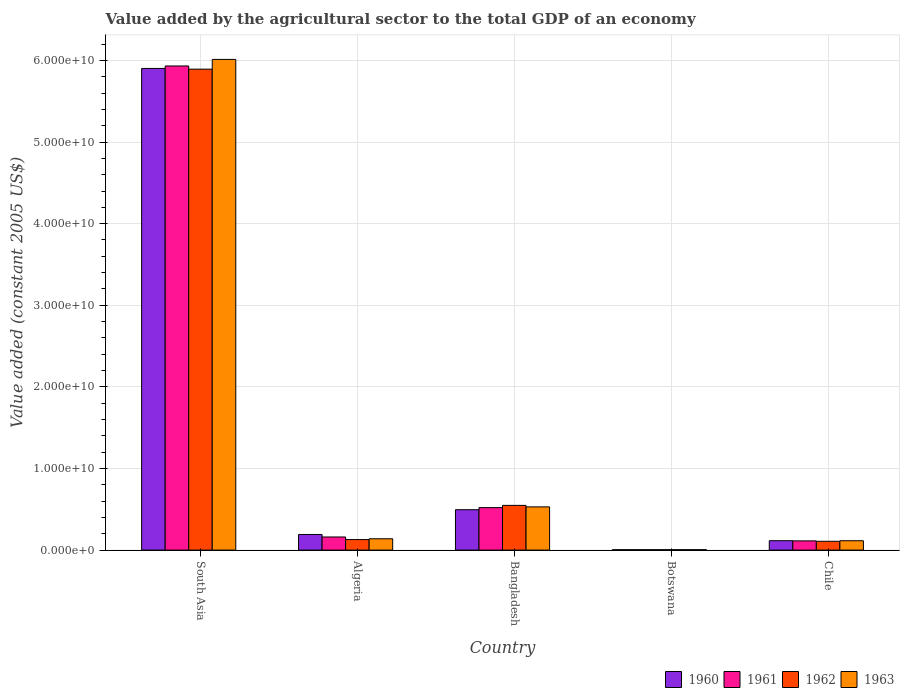How many different coloured bars are there?
Make the answer very short. 4. Are the number of bars per tick equal to the number of legend labels?
Provide a succinct answer. Yes. How many bars are there on the 1st tick from the left?
Your answer should be compact. 4. What is the label of the 4th group of bars from the left?
Provide a succinct answer. Botswana. In how many cases, is the number of bars for a given country not equal to the number of legend labels?
Give a very brief answer. 0. What is the value added by the agricultural sector in 1961 in Botswana?
Offer a terse response. 4.86e+07. Across all countries, what is the maximum value added by the agricultural sector in 1963?
Offer a terse response. 6.01e+1. Across all countries, what is the minimum value added by the agricultural sector in 1962?
Your answer should be compact. 5.04e+07. In which country was the value added by the agricultural sector in 1960 maximum?
Offer a very short reply. South Asia. In which country was the value added by the agricultural sector in 1960 minimum?
Make the answer very short. Botswana. What is the total value added by the agricultural sector in 1960 in the graph?
Your answer should be compact. 6.71e+1. What is the difference between the value added by the agricultural sector in 1963 in Bangladesh and that in South Asia?
Offer a very short reply. -5.48e+1. What is the difference between the value added by the agricultural sector in 1960 in Botswana and the value added by the agricultural sector in 1962 in Algeria?
Ensure brevity in your answer.  -1.24e+09. What is the average value added by the agricultural sector in 1961 per country?
Your response must be concise. 1.35e+1. What is the difference between the value added by the agricultural sector of/in 1963 and value added by the agricultural sector of/in 1962 in Botswana?
Ensure brevity in your answer.  1.75e+06. What is the ratio of the value added by the agricultural sector in 1962 in Bangladesh to that in South Asia?
Your answer should be very brief. 0.09. Is the value added by the agricultural sector in 1963 in Botswana less than that in Chile?
Make the answer very short. Yes. What is the difference between the highest and the second highest value added by the agricultural sector in 1960?
Your answer should be very brief. -3.03e+09. What is the difference between the highest and the lowest value added by the agricultural sector in 1963?
Your answer should be very brief. 6.01e+1. In how many countries, is the value added by the agricultural sector in 1962 greater than the average value added by the agricultural sector in 1962 taken over all countries?
Keep it short and to the point. 1. Is the sum of the value added by the agricultural sector in 1960 in Botswana and South Asia greater than the maximum value added by the agricultural sector in 1962 across all countries?
Make the answer very short. Yes. What does the 3rd bar from the right in South Asia represents?
Offer a very short reply. 1961. Are all the bars in the graph horizontal?
Ensure brevity in your answer.  No. How many countries are there in the graph?
Offer a terse response. 5. What is the difference between two consecutive major ticks on the Y-axis?
Provide a short and direct response. 1.00e+1. Are the values on the major ticks of Y-axis written in scientific E-notation?
Provide a short and direct response. Yes. Where does the legend appear in the graph?
Your answer should be very brief. Bottom right. How many legend labels are there?
Your answer should be compact. 4. What is the title of the graph?
Give a very brief answer. Value added by the agricultural sector to the total GDP of an economy. What is the label or title of the X-axis?
Your answer should be compact. Country. What is the label or title of the Y-axis?
Your answer should be very brief. Value added (constant 2005 US$). What is the Value added (constant 2005 US$) in 1960 in South Asia?
Make the answer very short. 5.90e+1. What is the Value added (constant 2005 US$) of 1961 in South Asia?
Your response must be concise. 5.93e+1. What is the Value added (constant 2005 US$) of 1962 in South Asia?
Your answer should be very brief. 5.89e+1. What is the Value added (constant 2005 US$) in 1963 in South Asia?
Give a very brief answer. 6.01e+1. What is the Value added (constant 2005 US$) in 1960 in Algeria?
Provide a succinct answer. 1.92e+09. What is the Value added (constant 2005 US$) in 1961 in Algeria?
Offer a very short reply. 1.61e+09. What is the Value added (constant 2005 US$) in 1962 in Algeria?
Offer a terse response. 1.29e+09. What is the Value added (constant 2005 US$) of 1963 in Algeria?
Ensure brevity in your answer.  1.39e+09. What is the Value added (constant 2005 US$) in 1960 in Bangladesh?
Provide a succinct answer. 4.95e+09. What is the Value added (constant 2005 US$) in 1961 in Bangladesh?
Provide a short and direct response. 5.21e+09. What is the Value added (constant 2005 US$) of 1962 in Bangladesh?
Provide a short and direct response. 5.48e+09. What is the Value added (constant 2005 US$) of 1963 in Bangladesh?
Offer a terse response. 5.30e+09. What is the Value added (constant 2005 US$) of 1960 in Botswana?
Make the answer very short. 4.74e+07. What is the Value added (constant 2005 US$) in 1961 in Botswana?
Make the answer very short. 4.86e+07. What is the Value added (constant 2005 US$) of 1962 in Botswana?
Give a very brief answer. 5.04e+07. What is the Value added (constant 2005 US$) of 1963 in Botswana?
Provide a succinct answer. 5.21e+07. What is the Value added (constant 2005 US$) in 1960 in Chile?
Ensure brevity in your answer.  1.15e+09. What is the Value added (constant 2005 US$) of 1961 in Chile?
Your answer should be very brief. 1.13e+09. What is the Value added (constant 2005 US$) in 1962 in Chile?
Provide a succinct answer. 1.08e+09. What is the Value added (constant 2005 US$) in 1963 in Chile?
Make the answer very short. 1.15e+09. Across all countries, what is the maximum Value added (constant 2005 US$) in 1960?
Ensure brevity in your answer.  5.90e+1. Across all countries, what is the maximum Value added (constant 2005 US$) of 1961?
Give a very brief answer. 5.93e+1. Across all countries, what is the maximum Value added (constant 2005 US$) in 1962?
Your response must be concise. 5.89e+1. Across all countries, what is the maximum Value added (constant 2005 US$) of 1963?
Provide a short and direct response. 6.01e+1. Across all countries, what is the minimum Value added (constant 2005 US$) of 1960?
Offer a very short reply. 4.74e+07. Across all countries, what is the minimum Value added (constant 2005 US$) of 1961?
Offer a terse response. 4.86e+07. Across all countries, what is the minimum Value added (constant 2005 US$) in 1962?
Your response must be concise. 5.04e+07. Across all countries, what is the minimum Value added (constant 2005 US$) of 1963?
Offer a very short reply. 5.21e+07. What is the total Value added (constant 2005 US$) in 1960 in the graph?
Your answer should be very brief. 6.71e+1. What is the total Value added (constant 2005 US$) of 1961 in the graph?
Provide a succinct answer. 6.73e+1. What is the total Value added (constant 2005 US$) in 1962 in the graph?
Keep it short and to the point. 6.68e+1. What is the total Value added (constant 2005 US$) of 1963 in the graph?
Offer a terse response. 6.80e+1. What is the difference between the Value added (constant 2005 US$) in 1960 in South Asia and that in Algeria?
Offer a terse response. 5.71e+1. What is the difference between the Value added (constant 2005 US$) of 1961 in South Asia and that in Algeria?
Provide a succinct answer. 5.77e+1. What is the difference between the Value added (constant 2005 US$) of 1962 in South Asia and that in Algeria?
Give a very brief answer. 5.76e+1. What is the difference between the Value added (constant 2005 US$) in 1963 in South Asia and that in Algeria?
Offer a terse response. 5.87e+1. What is the difference between the Value added (constant 2005 US$) of 1960 in South Asia and that in Bangladesh?
Your answer should be compact. 5.41e+1. What is the difference between the Value added (constant 2005 US$) in 1961 in South Asia and that in Bangladesh?
Give a very brief answer. 5.41e+1. What is the difference between the Value added (constant 2005 US$) of 1962 in South Asia and that in Bangladesh?
Provide a short and direct response. 5.35e+1. What is the difference between the Value added (constant 2005 US$) of 1963 in South Asia and that in Bangladesh?
Keep it short and to the point. 5.48e+1. What is the difference between the Value added (constant 2005 US$) of 1960 in South Asia and that in Botswana?
Offer a terse response. 5.90e+1. What is the difference between the Value added (constant 2005 US$) of 1961 in South Asia and that in Botswana?
Offer a very short reply. 5.93e+1. What is the difference between the Value added (constant 2005 US$) in 1962 in South Asia and that in Botswana?
Ensure brevity in your answer.  5.89e+1. What is the difference between the Value added (constant 2005 US$) of 1963 in South Asia and that in Botswana?
Your response must be concise. 6.01e+1. What is the difference between the Value added (constant 2005 US$) of 1960 in South Asia and that in Chile?
Provide a succinct answer. 5.79e+1. What is the difference between the Value added (constant 2005 US$) of 1961 in South Asia and that in Chile?
Keep it short and to the point. 5.82e+1. What is the difference between the Value added (constant 2005 US$) in 1962 in South Asia and that in Chile?
Keep it short and to the point. 5.79e+1. What is the difference between the Value added (constant 2005 US$) of 1963 in South Asia and that in Chile?
Make the answer very short. 5.90e+1. What is the difference between the Value added (constant 2005 US$) in 1960 in Algeria and that in Bangladesh?
Make the answer very short. -3.03e+09. What is the difference between the Value added (constant 2005 US$) of 1961 in Algeria and that in Bangladesh?
Offer a terse response. -3.60e+09. What is the difference between the Value added (constant 2005 US$) of 1962 in Algeria and that in Bangladesh?
Offer a terse response. -4.19e+09. What is the difference between the Value added (constant 2005 US$) in 1963 in Algeria and that in Bangladesh?
Make the answer very short. -3.91e+09. What is the difference between the Value added (constant 2005 US$) in 1960 in Algeria and that in Botswana?
Offer a terse response. 1.87e+09. What is the difference between the Value added (constant 2005 US$) in 1961 in Algeria and that in Botswana?
Keep it short and to the point. 1.56e+09. What is the difference between the Value added (constant 2005 US$) in 1962 in Algeria and that in Botswana?
Your response must be concise. 1.24e+09. What is the difference between the Value added (constant 2005 US$) in 1963 in Algeria and that in Botswana?
Provide a short and direct response. 1.34e+09. What is the difference between the Value added (constant 2005 US$) in 1960 in Algeria and that in Chile?
Your answer should be very brief. 7.63e+08. What is the difference between the Value added (constant 2005 US$) of 1961 in Algeria and that in Chile?
Your answer should be very brief. 4.78e+08. What is the difference between the Value added (constant 2005 US$) in 1962 in Algeria and that in Chile?
Provide a short and direct response. 2.11e+08. What is the difference between the Value added (constant 2005 US$) of 1963 in Algeria and that in Chile?
Offer a very short reply. 2.42e+08. What is the difference between the Value added (constant 2005 US$) of 1960 in Bangladesh and that in Botswana?
Offer a terse response. 4.90e+09. What is the difference between the Value added (constant 2005 US$) of 1961 in Bangladesh and that in Botswana?
Your answer should be compact. 5.16e+09. What is the difference between the Value added (constant 2005 US$) of 1962 in Bangladesh and that in Botswana?
Ensure brevity in your answer.  5.43e+09. What is the difference between the Value added (constant 2005 US$) in 1963 in Bangladesh and that in Botswana?
Ensure brevity in your answer.  5.24e+09. What is the difference between the Value added (constant 2005 US$) of 1960 in Bangladesh and that in Chile?
Your answer should be compact. 3.80e+09. What is the difference between the Value added (constant 2005 US$) in 1961 in Bangladesh and that in Chile?
Ensure brevity in your answer.  4.08e+09. What is the difference between the Value added (constant 2005 US$) in 1962 in Bangladesh and that in Chile?
Ensure brevity in your answer.  4.40e+09. What is the difference between the Value added (constant 2005 US$) of 1963 in Bangladesh and that in Chile?
Your answer should be very brief. 4.15e+09. What is the difference between the Value added (constant 2005 US$) of 1960 in Botswana and that in Chile?
Your answer should be compact. -1.10e+09. What is the difference between the Value added (constant 2005 US$) in 1961 in Botswana and that in Chile?
Ensure brevity in your answer.  -1.08e+09. What is the difference between the Value added (constant 2005 US$) of 1962 in Botswana and that in Chile?
Make the answer very short. -1.03e+09. What is the difference between the Value added (constant 2005 US$) in 1963 in Botswana and that in Chile?
Keep it short and to the point. -1.09e+09. What is the difference between the Value added (constant 2005 US$) in 1960 in South Asia and the Value added (constant 2005 US$) in 1961 in Algeria?
Your response must be concise. 5.74e+1. What is the difference between the Value added (constant 2005 US$) in 1960 in South Asia and the Value added (constant 2005 US$) in 1962 in Algeria?
Your response must be concise. 5.77e+1. What is the difference between the Value added (constant 2005 US$) of 1960 in South Asia and the Value added (constant 2005 US$) of 1963 in Algeria?
Offer a very short reply. 5.76e+1. What is the difference between the Value added (constant 2005 US$) of 1961 in South Asia and the Value added (constant 2005 US$) of 1962 in Algeria?
Offer a terse response. 5.80e+1. What is the difference between the Value added (constant 2005 US$) in 1961 in South Asia and the Value added (constant 2005 US$) in 1963 in Algeria?
Offer a terse response. 5.79e+1. What is the difference between the Value added (constant 2005 US$) in 1962 in South Asia and the Value added (constant 2005 US$) in 1963 in Algeria?
Provide a succinct answer. 5.75e+1. What is the difference between the Value added (constant 2005 US$) in 1960 in South Asia and the Value added (constant 2005 US$) in 1961 in Bangladesh?
Provide a short and direct response. 5.38e+1. What is the difference between the Value added (constant 2005 US$) of 1960 in South Asia and the Value added (constant 2005 US$) of 1962 in Bangladesh?
Your answer should be compact. 5.35e+1. What is the difference between the Value added (constant 2005 US$) of 1960 in South Asia and the Value added (constant 2005 US$) of 1963 in Bangladesh?
Your answer should be compact. 5.37e+1. What is the difference between the Value added (constant 2005 US$) of 1961 in South Asia and the Value added (constant 2005 US$) of 1962 in Bangladesh?
Give a very brief answer. 5.38e+1. What is the difference between the Value added (constant 2005 US$) of 1961 in South Asia and the Value added (constant 2005 US$) of 1963 in Bangladesh?
Provide a short and direct response. 5.40e+1. What is the difference between the Value added (constant 2005 US$) in 1962 in South Asia and the Value added (constant 2005 US$) in 1963 in Bangladesh?
Make the answer very short. 5.36e+1. What is the difference between the Value added (constant 2005 US$) of 1960 in South Asia and the Value added (constant 2005 US$) of 1961 in Botswana?
Offer a terse response. 5.90e+1. What is the difference between the Value added (constant 2005 US$) of 1960 in South Asia and the Value added (constant 2005 US$) of 1962 in Botswana?
Your response must be concise. 5.90e+1. What is the difference between the Value added (constant 2005 US$) in 1960 in South Asia and the Value added (constant 2005 US$) in 1963 in Botswana?
Keep it short and to the point. 5.90e+1. What is the difference between the Value added (constant 2005 US$) of 1961 in South Asia and the Value added (constant 2005 US$) of 1962 in Botswana?
Give a very brief answer. 5.93e+1. What is the difference between the Value added (constant 2005 US$) of 1961 in South Asia and the Value added (constant 2005 US$) of 1963 in Botswana?
Provide a succinct answer. 5.93e+1. What is the difference between the Value added (constant 2005 US$) in 1962 in South Asia and the Value added (constant 2005 US$) in 1963 in Botswana?
Offer a terse response. 5.89e+1. What is the difference between the Value added (constant 2005 US$) of 1960 in South Asia and the Value added (constant 2005 US$) of 1961 in Chile?
Your response must be concise. 5.79e+1. What is the difference between the Value added (constant 2005 US$) of 1960 in South Asia and the Value added (constant 2005 US$) of 1962 in Chile?
Keep it short and to the point. 5.79e+1. What is the difference between the Value added (constant 2005 US$) of 1960 in South Asia and the Value added (constant 2005 US$) of 1963 in Chile?
Your response must be concise. 5.79e+1. What is the difference between the Value added (constant 2005 US$) in 1961 in South Asia and the Value added (constant 2005 US$) in 1962 in Chile?
Provide a succinct answer. 5.82e+1. What is the difference between the Value added (constant 2005 US$) of 1961 in South Asia and the Value added (constant 2005 US$) of 1963 in Chile?
Your answer should be very brief. 5.82e+1. What is the difference between the Value added (constant 2005 US$) of 1962 in South Asia and the Value added (constant 2005 US$) of 1963 in Chile?
Offer a terse response. 5.78e+1. What is the difference between the Value added (constant 2005 US$) of 1960 in Algeria and the Value added (constant 2005 US$) of 1961 in Bangladesh?
Keep it short and to the point. -3.29e+09. What is the difference between the Value added (constant 2005 US$) of 1960 in Algeria and the Value added (constant 2005 US$) of 1962 in Bangladesh?
Offer a terse response. -3.56e+09. What is the difference between the Value added (constant 2005 US$) of 1960 in Algeria and the Value added (constant 2005 US$) of 1963 in Bangladesh?
Provide a succinct answer. -3.38e+09. What is the difference between the Value added (constant 2005 US$) of 1961 in Algeria and the Value added (constant 2005 US$) of 1962 in Bangladesh?
Your answer should be very brief. -3.87e+09. What is the difference between the Value added (constant 2005 US$) in 1961 in Algeria and the Value added (constant 2005 US$) in 1963 in Bangladesh?
Give a very brief answer. -3.69e+09. What is the difference between the Value added (constant 2005 US$) of 1962 in Algeria and the Value added (constant 2005 US$) of 1963 in Bangladesh?
Make the answer very short. -4.00e+09. What is the difference between the Value added (constant 2005 US$) of 1960 in Algeria and the Value added (constant 2005 US$) of 1961 in Botswana?
Provide a short and direct response. 1.87e+09. What is the difference between the Value added (constant 2005 US$) in 1960 in Algeria and the Value added (constant 2005 US$) in 1962 in Botswana?
Your response must be concise. 1.86e+09. What is the difference between the Value added (constant 2005 US$) of 1960 in Algeria and the Value added (constant 2005 US$) of 1963 in Botswana?
Keep it short and to the point. 1.86e+09. What is the difference between the Value added (constant 2005 US$) of 1961 in Algeria and the Value added (constant 2005 US$) of 1962 in Botswana?
Offer a terse response. 1.56e+09. What is the difference between the Value added (constant 2005 US$) of 1961 in Algeria and the Value added (constant 2005 US$) of 1963 in Botswana?
Offer a very short reply. 1.56e+09. What is the difference between the Value added (constant 2005 US$) of 1962 in Algeria and the Value added (constant 2005 US$) of 1963 in Botswana?
Provide a succinct answer. 1.24e+09. What is the difference between the Value added (constant 2005 US$) of 1960 in Algeria and the Value added (constant 2005 US$) of 1961 in Chile?
Ensure brevity in your answer.  7.85e+08. What is the difference between the Value added (constant 2005 US$) in 1960 in Algeria and the Value added (constant 2005 US$) in 1962 in Chile?
Provide a succinct answer. 8.36e+08. What is the difference between the Value added (constant 2005 US$) in 1960 in Algeria and the Value added (constant 2005 US$) in 1963 in Chile?
Your answer should be very brief. 7.69e+08. What is the difference between the Value added (constant 2005 US$) of 1961 in Algeria and the Value added (constant 2005 US$) of 1962 in Chile?
Your answer should be compact. 5.29e+08. What is the difference between the Value added (constant 2005 US$) of 1961 in Algeria and the Value added (constant 2005 US$) of 1963 in Chile?
Provide a short and direct response. 4.62e+08. What is the difference between the Value added (constant 2005 US$) in 1962 in Algeria and the Value added (constant 2005 US$) in 1963 in Chile?
Give a very brief answer. 1.44e+08. What is the difference between the Value added (constant 2005 US$) of 1960 in Bangladesh and the Value added (constant 2005 US$) of 1961 in Botswana?
Your answer should be compact. 4.90e+09. What is the difference between the Value added (constant 2005 US$) in 1960 in Bangladesh and the Value added (constant 2005 US$) in 1962 in Botswana?
Give a very brief answer. 4.90e+09. What is the difference between the Value added (constant 2005 US$) in 1960 in Bangladesh and the Value added (constant 2005 US$) in 1963 in Botswana?
Your response must be concise. 4.90e+09. What is the difference between the Value added (constant 2005 US$) of 1961 in Bangladesh and the Value added (constant 2005 US$) of 1962 in Botswana?
Provide a short and direct response. 5.16e+09. What is the difference between the Value added (constant 2005 US$) of 1961 in Bangladesh and the Value added (constant 2005 US$) of 1963 in Botswana?
Your response must be concise. 5.15e+09. What is the difference between the Value added (constant 2005 US$) of 1962 in Bangladesh and the Value added (constant 2005 US$) of 1963 in Botswana?
Your answer should be compact. 5.43e+09. What is the difference between the Value added (constant 2005 US$) in 1960 in Bangladesh and the Value added (constant 2005 US$) in 1961 in Chile?
Your response must be concise. 3.82e+09. What is the difference between the Value added (constant 2005 US$) of 1960 in Bangladesh and the Value added (constant 2005 US$) of 1962 in Chile?
Keep it short and to the point. 3.87e+09. What is the difference between the Value added (constant 2005 US$) in 1960 in Bangladesh and the Value added (constant 2005 US$) in 1963 in Chile?
Offer a terse response. 3.80e+09. What is the difference between the Value added (constant 2005 US$) in 1961 in Bangladesh and the Value added (constant 2005 US$) in 1962 in Chile?
Provide a succinct answer. 4.13e+09. What is the difference between the Value added (constant 2005 US$) in 1961 in Bangladesh and the Value added (constant 2005 US$) in 1963 in Chile?
Offer a very short reply. 4.06e+09. What is the difference between the Value added (constant 2005 US$) of 1962 in Bangladesh and the Value added (constant 2005 US$) of 1963 in Chile?
Provide a succinct answer. 4.33e+09. What is the difference between the Value added (constant 2005 US$) of 1960 in Botswana and the Value added (constant 2005 US$) of 1961 in Chile?
Offer a terse response. -1.08e+09. What is the difference between the Value added (constant 2005 US$) in 1960 in Botswana and the Value added (constant 2005 US$) in 1962 in Chile?
Offer a very short reply. -1.03e+09. What is the difference between the Value added (constant 2005 US$) of 1960 in Botswana and the Value added (constant 2005 US$) of 1963 in Chile?
Keep it short and to the point. -1.10e+09. What is the difference between the Value added (constant 2005 US$) in 1961 in Botswana and the Value added (constant 2005 US$) in 1962 in Chile?
Provide a succinct answer. -1.03e+09. What is the difference between the Value added (constant 2005 US$) of 1961 in Botswana and the Value added (constant 2005 US$) of 1963 in Chile?
Provide a short and direct response. -1.10e+09. What is the difference between the Value added (constant 2005 US$) in 1962 in Botswana and the Value added (constant 2005 US$) in 1963 in Chile?
Provide a short and direct response. -1.10e+09. What is the average Value added (constant 2005 US$) of 1960 per country?
Your answer should be very brief. 1.34e+1. What is the average Value added (constant 2005 US$) in 1961 per country?
Your response must be concise. 1.35e+1. What is the average Value added (constant 2005 US$) of 1962 per country?
Your answer should be compact. 1.34e+1. What is the average Value added (constant 2005 US$) of 1963 per country?
Ensure brevity in your answer.  1.36e+1. What is the difference between the Value added (constant 2005 US$) in 1960 and Value added (constant 2005 US$) in 1961 in South Asia?
Your answer should be very brief. -3.02e+08. What is the difference between the Value added (constant 2005 US$) in 1960 and Value added (constant 2005 US$) in 1962 in South Asia?
Ensure brevity in your answer.  8.71e+07. What is the difference between the Value added (constant 2005 US$) in 1960 and Value added (constant 2005 US$) in 1963 in South Asia?
Ensure brevity in your answer.  -1.11e+09. What is the difference between the Value added (constant 2005 US$) in 1961 and Value added (constant 2005 US$) in 1962 in South Asia?
Provide a short and direct response. 3.89e+08. What is the difference between the Value added (constant 2005 US$) of 1961 and Value added (constant 2005 US$) of 1963 in South Asia?
Your answer should be very brief. -8.04e+08. What is the difference between the Value added (constant 2005 US$) in 1962 and Value added (constant 2005 US$) in 1963 in South Asia?
Ensure brevity in your answer.  -1.19e+09. What is the difference between the Value added (constant 2005 US$) in 1960 and Value added (constant 2005 US$) in 1961 in Algeria?
Offer a very short reply. 3.07e+08. What is the difference between the Value added (constant 2005 US$) of 1960 and Value added (constant 2005 US$) of 1962 in Algeria?
Keep it short and to the point. 6.25e+08. What is the difference between the Value added (constant 2005 US$) of 1960 and Value added (constant 2005 US$) of 1963 in Algeria?
Your response must be concise. 5.27e+08. What is the difference between the Value added (constant 2005 US$) in 1961 and Value added (constant 2005 US$) in 1962 in Algeria?
Your answer should be compact. 3.18e+08. What is the difference between the Value added (constant 2005 US$) in 1961 and Value added (constant 2005 US$) in 1963 in Algeria?
Provide a succinct answer. 2.20e+08. What is the difference between the Value added (constant 2005 US$) in 1962 and Value added (constant 2005 US$) in 1963 in Algeria?
Your answer should be very brief. -9.79e+07. What is the difference between the Value added (constant 2005 US$) of 1960 and Value added (constant 2005 US$) of 1961 in Bangladesh?
Provide a short and direct response. -2.58e+08. What is the difference between the Value added (constant 2005 US$) in 1960 and Value added (constant 2005 US$) in 1962 in Bangladesh?
Provide a short and direct response. -5.31e+08. What is the difference between the Value added (constant 2005 US$) in 1960 and Value added (constant 2005 US$) in 1963 in Bangladesh?
Your response must be concise. -3.47e+08. What is the difference between the Value added (constant 2005 US$) in 1961 and Value added (constant 2005 US$) in 1962 in Bangladesh?
Your answer should be very brief. -2.73e+08. What is the difference between the Value added (constant 2005 US$) in 1961 and Value added (constant 2005 US$) in 1963 in Bangladesh?
Offer a terse response. -8.88e+07. What is the difference between the Value added (constant 2005 US$) of 1962 and Value added (constant 2005 US$) of 1963 in Bangladesh?
Your answer should be very brief. 1.84e+08. What is the difference between the Value added (constant 2005 US$) in 1960 and Value added (constant 2005 US$) in 1961 in Botswana?
Offer a terse response. -1.17e+06. What is the difference between the Value added (constant 2005 US$) in 1960 and Value added (constant 2005 US$) in 1962 in Botswana?
Your answer should be compact. -2.92e+06. What is the difference between the Value added (constant 2005 US$) in 1960 and Value added (constant 2005 US$) in 1963 in Botswana?
Make the answer very short. -4.67e+06. What is the difference between the Value added (constant 2005 US$) in 1961 and Value added (constant 2005 US$) in 1962 in Botswana?
Give a very brief answer. -1.75e+06. What is the difference between the Value added (constant 2005 US$) in 1961 and Value added (constant 2005 US$) in 1963 in Botswana?
Your answer should be very brief. -3.51e+06. What is the difference between the Value added (constant 2005 US$) in 1962 and Value added (constant 2005 US$) in 1963 in Botswana?
Ensure brevity in your answer.  -1.75e+06. What is the difference between the Value added (constant 2005 US$) in 1960 and Value added (constant 2005 US$) in 1961 in Chile?
Keep it short and to the point. 2.12e+07. What is the difference between the Value added (constant 2005 US$) in 1960 and Value added (constant 2005 US$) in 1962 in Chile?
Your answer should be compact. 7.27e+07. What is the difference between the Value added (constant 2005 US$) of 1960 and Value added (constant 2005 US$) of 1963 in Chile?
Provide a short and direct response. 5.74e+06. What is the difference between the Value added (constant 2005 US$) of 1961 and Value added (constant 2005 US$) of 1962 in Chile?
Offer a very short reply. 5.15e+07. What is the difference between the Value added (constant 2005 US$) in 1961 and Value added (constant 2005 US$) in 1963 in Chile?
Your response must be concise. -1.54e+07. What is the difference between the Value added (constant 2005 US$) of 1962 and Value added (constant 2005 US$) of 1963 in Chile?
Make the answer very short. -6.69e+07. What is the ratio of the Value added (constant 2005 US$) of 1960 in South Asia to that in Algeria?
Offer a terse response. 30.81. What is the ratio of the Value added (constant 2005 US$) of 1961 in South Asia to that in Algeria?
Your answer should be compact. 36.88. What is the ratio of the Value added (constant 2005 US$) of 1962 in South Asia to that in Algeria?
Your response must be concise. 45.68. What is the ratio of the Value added (constant 2005 US$) in 1963 in South Asia to that in Algeria?
Your response must be concise. 43.31. What is the ratio of the Value added (constant 2005 US$) of 1960 in South Asia to that in Bangladesh?
Offer a terse response. 11.93. What is the ratio of the Value added (constant 2005 US$) in 1961 in South Asia to that in Bangladesh?
Your response must be concise. 11.39. What is the ratio of the Value added (constant 2005 US$) of 1962 in South Asia to that in Bangladesh?
Keep it short and to the point. 10.75. What is the ratio of the Value added (constant 2005 US$) in 1963 in South Asia to that in Bangladesh?
Give a very brief answer. 11.35. What is the ratio of the Value added (constant 2005 US$) in 1960 in South Asia to that in Botswana?
Your answer should be compact. 1243.88. What is the ratio of the Value added (constant 2005 US$) in 1961 in South Asia to that in Botswana?
Keep it short and to the point. 1220.19. What is the ratio of the Value added (constant 2005 US$) in 1962 in South Asia to that in Botswana?
Keep it short and to the point. 1170. What is the ratio of the Value added (constant 2005 US$) in 1963 in South Asia to that in Botswana?
Give a very brief answer. 1153.54. What is the ratio of the Value added (constant 2005 US$) in 1960 in South Asia to that in Chile?
Provide a short and direct response. 51.24. What is the ratio of the Value added (constant 2005 US$) in 1961 in South Asia to that in Chile?
Your response must be concise. 52.46. What is the ratio of the Value added (constant 2005 US$) of 1962 in South Asia to that in Chile?
Provide a short and direct response. 54.61. What is the ratio of the Value added (constant 2005 US$) of 1963 in South Asia to that in Chile?
Ensure brevity in your answer.  52.46. What is the ratio of the Value added (constant 2005 US$) of 1960 in Algeria to that in Bangladesh?
Ensure brevity in your answer.  0.39. What is the ratio of the Value added (constant 2005 US$) of 1961 in Algeria to that in Bangladesh?
Your answer should be very brief. 0.31. What is the ratio of the Value added (constant 2005 US$) of 1962 in Algeria to that in Bangladesh?
Give a very brief answer. 0.24. What is the ratio of the Value added (constant 2005 US$) in 1963 in Algeria to that in Bangladesh?
Offer a very short reply. 0.26. What is the ratio of the Value added (constant 2005 US$) in 1960 in Algeria to that in Botswana?
Offer a very short reply. 40.37. What is the ratio of the Value added (constant 2005 US$) of 1961 in Algeria to that in Botswana?
Keep it short and to the point. 33.08. What is the ratio of the Value added (constant 2005 US$) in 1962 in Algeria to that in Botswana?
Make the answer very short. 25.62. What is the ratio of the Value added (constant 2005 US$) in 1963 in Algeria to that in Botswana?
Offer a terse response. 26.63. What is the ratio of the Value added (constant 2005 US$) in 1960 in Algeria to that in Chile?
Your answer should be very brief. 1.66. What is the ratio of the Value added (constant 2005 US$) in 1961 in Algeria to that in Chile?
Provide a short and direct response. 1.42. What is the ratio of the Value added (constant 2005 US$) of 1962 in Algeria to that in Chile?
Give a very brief answer. 1.2. What is the ratio of the Value added (constant 2005 US$) of 1963 in Algeria to that in Chile?
Keep it short and to the point. 1.21. What is the ratio of the Value added (constant 2005 US$) in 1960 in Bangladesh to that in Botswana?
Offer a very short reply. 104.3. What is the ratio of the Value added (constant 2005 US$) of 1961 in Bangladesh to that in Botswana?
Your response must be concise. 107.09. What is the ratio of the Value added (constant 2005 US$) in 1962 in Bangladesh to that in Botswana?
Give a very brief answer. 108.79. What is the ratio of the Value added (constant 2005 US$) of 1963 in Bangladesh to that in Botswana?
Offer a terse response. 101.59. What is the ratio of the Value added (constant 2005 US$) of 1960 in Bangladesh to that in Chile?
Make the answer very short. 4.3. What is the ratio of the Value added (constant 2005 US$) of 1961 in Bangladesh to that in Chile?
Your answer should be very brief. 4.6. What is the ratio of the Value added (constant 2005 US$) in 1962 in Bangladesh to that in Chile?
Keep it short and to the point. 5.08. What is the ratio of the Value added (constant 2005 US$) of 1963 in Bangladesh to that in Chile?
Your response must be concise. 4.62. What is the ratio of the Value added (constant 2005 US$) in 1960 in Botswana to that in Chile?
Your response must be concise. 0.04. What is the ratio of the Value added (constant 2005 US$) in 1961 in Botswana to that in Chile?
Make the answer very short. 0.04. What is the ratio of the Value added (constant 2005 US$) of 1962 in Botswana to that in Chile?
Offer a terse response. 0.05. What is the ratio of the Value added (constant 2005 US$) in 1963 in Botswana to that in Chile?
Ensure brevity in your answer.  0.05. What is the difference between the highest and the second highest Value added (constant 2005 US$) in 1960?
Your response must be concise. 5.41e+1. What is the difference between the highest and the second highest Value added (constant 2005 US$) of 1961?
Keep it short and to the point. 5.41e+1. What is the difference between the highest and the second highest Value added (constant 2005 US$) in 1962?
Make the answer very short. 5.35e+1. What is the difference between the highest and the second highest Value added (constant 2005 US$) in 1963?
Provide a short and direct response. 5.48e+1. What is the difference between the highest and the lowest Value added (constant 2005 US$) in 1960?
Keep it short and to the point. 5.90e+1. What is the difference between the highest and the lowest Value added (constant 2005 US$) in 1961?
Ensure brevity in your answer.  5.93e+1. What is the difference between the highest and the lowest Value added (constant 2005 US$) in 1962?
Offer a very short reply. 5.89e+1. What is the difference between the highest and the lowest Value added (constant 2005 US$) in 1963?
Provide a succinct answer. 6.01e+1. 